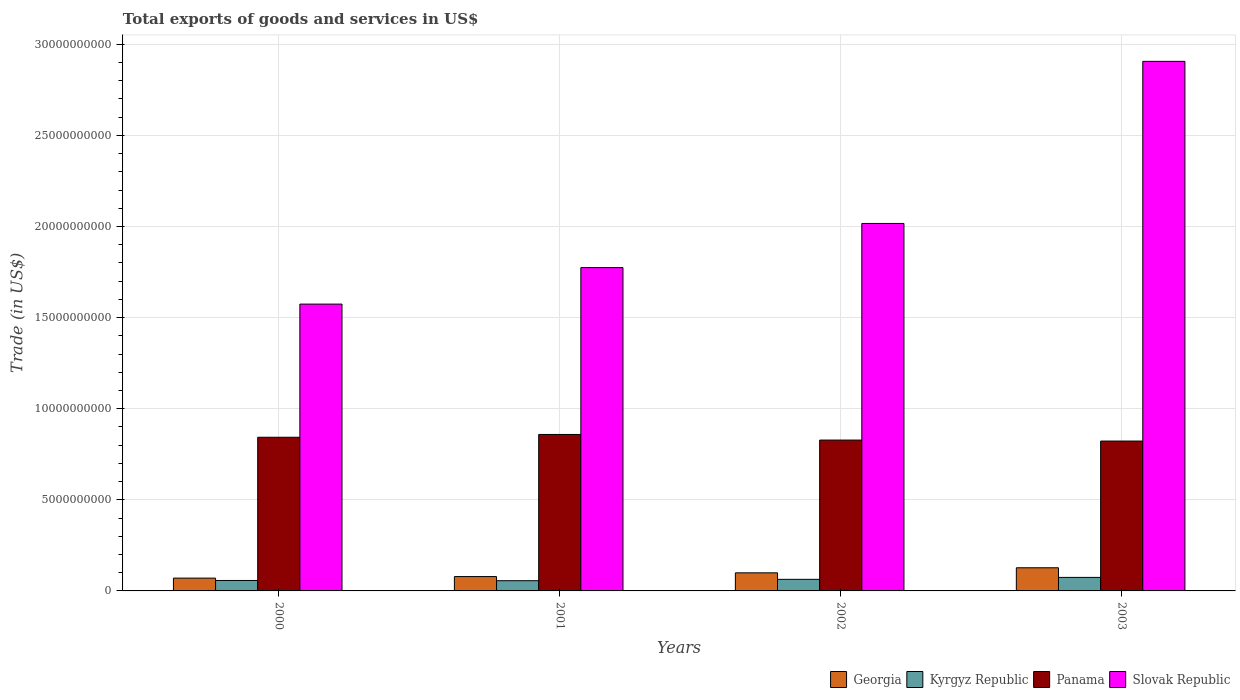How many groups of bars are there?
Your response must be concise. 4. Are the number of bars per tick equal to the number of legend labels?
Your answer should be very brief. Yes. Are the number of bars on each tick of the X-axis equal?
Make the answer very short. Yes. How many bars are there on the 3rd tick from the left?
Keep it short and to the point. 4. What is the total exports of goods and services in Slovak Republic in 2003?
Provide a short and direct response. 2.91e+1. Across all years, what is the maximum total exports of goods and services in Kyrgyz Republic?
Provide a short and direct response. 7.42e+08. Across all years, what is the minimum total exports of goods and services in Slovak Republic?
Ensure brevity in your answer.  1.57e+1. In which year was the total exports of goods and services in Georgia maximum?
Offer a terse response. 2003. In which year was the total exports of goods and services in Panama minimum?
Make the answer very short. 2003. What is the total total exports of goods and services in Panama in the graph?
Ensure brevity in your answer.  3.35e+1. What is the difference between the total exports of goods and services in Georgia in 2002 and that in 2003?
Your answer should be compact. -2.78e+08. What is the difference between the total exports of goods and services in Georgia in 2000 and the total exports of goods and services in Kyrgyz Republic in 2001?
Provide a succinct answer. 1.43e+08. What is the average total exports of goods and services in Georgia per year?
Your answer should be very brief. 9.38e+08. In the year 2003, what is the difference between the total exports of goods and services in Panama and total exports of goods and services in Slovak Republic?
Your response must be concise. -2.08e+1. What is the ratio of the total exports of goods and services in Slovak Republic in 2000 to that in 2003?
Offer a very short reply. 0.54. Is the total exports of goods and services in Kyrgyz Republic in 2001 less than that in 2002?
Keep it short and to the point. Yes. Is the difference between the total exports of goods and services in Panama in 2000 and 2002 greater than the difference between the total exports of goods and services in Slovak Republic in 2000 and 2002?
Give a very brief answer. Yes. What is the difference between the highest and the second highest total exports of goods and services in Slovak Republic?
Provide a short and direct response. 8.90e+09. What is the difference between the highest and the lowest total exports of goods and services in Panama?
Make the answer very short. 3.61e+08. Is it the case that in every year, the sum of the total exports of goods and services in Kyrgyz Republic and total exports of goods and services in Georgia is greater than the sum of total exports of goods and services in Panama and total exports of goods and services in Slovak Republic?
Ensure brevity in your answer.  No. What does the 2nd bar from the left in 2001 represents?
Provide a succinct answer. Kyrgyz Republic. What does the 1st bar from the right in 2002 represents?
Your answer should be very brief. Slovak Republic. How many years are there in the graph?
Your response must be concise. 4. Does the graph contain any zero values?
Make the answer very short. No. How many legend labels are there?
Provide a short and direct response. 4. How are the legend labels stacked?
Provide a short and direct response. Horizontal. What is the title of the graph?
Keep it short and to the point. Total exports of goods and services in US$. Does "Colombia" appear as one of the legend labels in the graph?
Your answer should be compact. No. What is the label or title of the Y-axis?
Offer a terse response. Trade (in US$). What is the Trade (in US$) in Georgia in 2000?
Provide a succinct answer. 7.03e+08. What is the Trade (in US$) in Kyrgyz Republic in 2000?
Your answer should be compact. 5.73e+08. What is the Trade (in US$) in Panama in 2000?
Ensure brevity in your answer.  8.43e+09. What is the Trade (in US$) in Slovak Republic in 2000?
Provide a succinct answer. 1.57e+1. What is the Trade (in US$) of Georgia in 2001?
Ensure brevity in your answer.  7.88e+08. What is the Trade (in US$) in Kyrgyz Republic in 2001?
Give a very brief answer. 5.60e+08. What is the Trade (in US$) of Panama in 2001?
Offer a very short reply. 8.59e+09. What is the Trade (in US$) in Slovak Republic in 2001?
Provide a short and direct response. 1.77e+1. What is the Trade (in US$) in Georgia in 2002?
Offer a very short reply. 9.93e+08. What is the Trade (in US$) of Kyrgyz Republic in 2002?
Your response must be concise. 6.36e+08. What is the Trade (in US$) of Panama in 2002?
Your answer should be very brief. 8.28e+09. What is the Trade (in US$) in Slovak Republic in 2002?
Ensure brevity in your answer.  2.02e+1. What is the Trade (in US$) in Georgia in 2003?
Your answer should be compact. 1.27e+09. What is the Trade (in US$) in Kyrgyz Republic in 2003?
Make the answer very short. 7.42e+08. What is the Trade (in US$) of Panama in 2003?
Make the answer very short. 8.23e+09. What is the Trade (in US$) in Slovak Republic in 2003?
Make the answer very short. 2.91e+1. Across all years, what is the maximum Trade (in US$) of Georgia?
Make the answer very short. 1.27e+09. Across all years, what is the maximum Trade (in US$) of Kyrgyz Republic?
Keep it short and to the point. 7.42e+08. Across all years, what is the maximum Trade (in US$) of Panama?
Provide a short and direct response. 8.59e+09. Across all years, what is the maximum Trade (in US$) in Slovak Republic?
Your answer should be very brief. 2.91e+1. Across all years, what is the minimum Trade (in US$) in Georgia?
Your answer should be very brief. 7.03e+08. Across all years, what is the minimum Trade (in US$) in Kyrgyz Republic?
Provide a short and direct response. 5.60e+08. Across all years, what is the minimum Trade (in US$) of Panama?
Your answer should be very brief. 8.23e+09. Across all years, what is the minimum Trade (in US$) of Slovak Republic?
Ensure brevity in your answer.  1.57e+1. What is the total Trade (in US$) of Georgia in the graph?
Offer a terse response. 3.75e+09. What is the total Trade (in US$) of Kyrgyz Republic in the graph?
Make the answer very short. 2.51e+09. What is the total Trade (in US$) of Panama in the graph?
Offer a terse response. 3.35e+1. What is the total Trade (in US$) of Slovak Republic in the graph?
Ensure brevity in your answer.  8.27e+1. What is the difference between the Trade (in US$) of Georgia in 2000 and that in 2001?
Provide a short and direct response. -8.45e+07. What is the difference between the Trade (in US$) of Kyrgyz Republic in 2000 and that in 2001?
Your answer should be very brief. 1.31e+07. What is the difference between the Trade (in US$) in Panama in 2000 and that in 2001?
Provide a short and direct response. -1.53e+08. What is the difference between the Trade (in US$) in Slovak Republic in 2000 and that in 2001?
Ensure brevity in your answer.  -2.00e+09. What is the difference between the Trade (in US$) of Georgia in 2000 and that in 2002?
Offer a terse response. -2.90e+08. What is the difference between the Trade (in US$) in Kyrgyz Republic in 2000 and that in 2002?
Give a very brief answer. -6.24e+07. What is the difference between the Trade (in US$) of Panama in 2000 and that in 2002?
Offer a terse response. 1.55e+08. What is the difference between the Trade (in US$) of Slovak Republic in 2000 and that in 2002?
Offer a terse response. -4.43e+09. What is the difference between the Trade (in US$) of Georgia in 2000 and that in 2003?
Make the answer very short. -5.68e+08. What is the difference between the Trade (in US$) in Kyrgyz Republic in 2000 and that in 2003?
Your response must be concise. -1.69e+08. What is the difference between the Trade (in US$) in Panama in 2000 and that in 2003?
Provide a succinct answer. 2.08e+08. What is the difference between the Trade (in US$) in Slovak Republic in 2000 and that in 2003?
Keep it short and to the point. -1.33e+1. What is the difference between the Trade (in US$) of Georgia in 2001 and that in 2002?
Offer a very short reply. -2.05e+08. What is the difference between the Trade (in US$) in Kyrgyz Republic in 2001 and that in 2002?
Your response must be concise. -7.54e+07. What is the difference between the Trade (in US$) in Panama in 2001 and that in 2002?
Your answer should be compact. 3.08e+08. What is the difference between the Trade (in US$) in Slovak Republic in 2001 and that in 2002?
Offer a very short reply. -2.42e+09. What is the difference between the Trade (in US$) of Georgia in 2001 and that in 2003?
Provide a short and direct response. -4.83e+08. What is the difference between the Trade (in US$) of Kyrgyz Republic in 2001 and that in 2003?
Give a very brief answer. -1.82e+08. What is the difference between the Trade (in US$) in Panama in 2001 and that in 2003?
Keep it short and to the point. 3.61e+08. What is the difference between the Trade (in US$) in Slovak Republic in 2001 and that in 2003?
Ensure brevity in your answer.  -1.13e+1. What is the difference between the Trade (in US$) of Georgia in 2002 and that in 2003?
Make the answer very short. -2.78e+08. What is the difference between the Trade (in US$) of Kyrgyz Republic in 2002 and that in 2003?
Provide a short and direct response. -1.07e+08. What is the difference between the Trade (in US$) in Panama in 2002 and that in 2003?
Keep it short and to the point. 5.37e+07. What is the difference between the Trade (in US$) in Slovak Republic in 2002 and that in 2003?
Make the answer very short. -8.90e+09. What is the difference between the Trade (in US$) in Georgia in 2000 and the Trade (in US$) in Kyrgyz Republic in 2001?
Offer a very short reply. 1.43e+08. What is the difference between the Trade (in US$) of Georgia in 2000 and the Trade (in US$) of Panama in 2001?
Offer a terse response. -7.88e+09. What is the difference between the Trade (in US$) of Georgia in 2000 and the Trade (in US$) of Slovak Republic in 2001?
Keep it short and to the point. -1.70e+1. What is the difference between the Trade (in US$) of Kyrgyz Republic in 2000 and the Trade (in US$) of Panama in 2001?
Offer a terse response. -8.01e+09. What is the difference between the Trade (in US$) of Kyrgyz Republic in 2000 and the Trade (in US$) of Slovak Republic in 2001?
Your response must be concise. -1.72e+1. What is the difference between the Trade (in US$) in Panama in 2000 and the Trade (in US$) in Slovak Republic in 2001?
Your answer should be compact. -9.31e+09. What is the difference between the Trade (in US$) of Georgia in 2000 and the Trade (in US$) of Kyrgyz Republic in 2002?
Offer a terse response. 6.75e+07. What is the difference between the Trade (in US$) of Georgia in 2000 and the Trade (in US$) of Panama in 2002?
Offer a very short reply. -7.58e+09. What is the difference between the Trade (in US$) of Georgia in 2000 and the Trade (in US$) of Slovak Republic in 2002?
Offer a terse response. -1.95e+1. What is the difference between the Trade (in US$) of Kyrgyz Republic in 2000 and the Trade (in US$) of Panama in 2002?
Offer a very short reply. -7.71e+09. What is the difference between the Trade (in US$) of Kyrgyz Republic in 2000 and the Trade (in US$) of Slovak Republic in 2002?
Keep it short and to the point. -1.96e+1. What is the difference between the Trade (in US$) of Panama in 2000 and the Trade (in US$) of Slovak Republic in 2002?
Offer a very short reply. -1.17e+1. What is the difference between the Trade (in US$) in Georgia in 2000 and the Trade (in US$) in Kyrgyz Republic in 2003?
Your answer should be compact. -3.92e+07. What is the difference between the Trade (in US$) of Georgia in 2000 and the Trade (in US$) of Panama in 2003?
Keep it short and to the point. -7.52e+09. What is the difference between the Trade (in US$) in Georgia in 2000 and the Trade (in US$) in Slovak Republic in 2003?
Your answer should be compact. -2.84e+1. What is the difference between the Trade (in US$) of Kyrgyz Republic in 2000 and the Trade (in US$) of Panama in 2003?
Provide a succinct answer. -7.65e+09. What is the difference between the Trade (in US$) of Kyrgyz Republic in 2000 and the Trade (in US$) of Slovak Republic in 2003?
Your answer should be compact. -2.85e+1. What is the difference between the Trade (in US$) in Panama in 2000 and the Trade (in US$) in Slovak Republic in 2003?
Make the answer very short. -2.06e+1. What is the difference between the Trade (in US$) of Georgia in 2001 and the Trade (in US$) of Kyrgyz Republic in 2002?
Provide a short and direct response. 1.52e+08. What is the difference between the Trade (in US$) of Georgia in 2001 and the Trade (in US$) of Panama in 2002?
Offer a very short reply. -7.49e+09. What is the difference between the Trade (in US$) of Georgia in 2001 and the Trade (in US$) of Slovak Republic in 2002?
Your answer should be very brief. -1.94e+1. What is the difference between the Trade (in US$) in Kyrgyz Republic in 2001 and the Trade (in US$) in Panama in 2002?
Keep it short and to the point. -7.72e+09. What is the difference between the Trade (in US$) of Kyrgyz Republic in 2001 and the Trade (in US$) of Slovak Republic in 2002?
Keep it short and to the point. -1.96e+1. What is the difference between the Trade (in US$) of Panama in 2001 and the Trade (in US$) of Slovak Republic in 2002?
Your answer should be very brief. -1.16e+1. What is the difference between the Trade (in US$) in Georgia in 2001 and the Trade (in US$) in Kyrgyz Republic in 2003?
Your response must be concise. 4.52e+07. What is the difference between the Trade (in US$) in Georgia in 2001 and the Trade (in US$) in Panama in 2003?
Offer a very short reply. -7.44e+09. What is the difference between the Trade (in US$) in Georgia in 2001 and the Trade (in US$) in Slovak Republic in 2003?
Make the answer very short. -2.83e+1. What is the difference between the Trade (in US$) of Kyrgyz Republic in 2001 and the Trade (in US$) of Panama in 2003?
Your answer should be very brief. -7.67e+09. What is the difference between the Trade (in US$) of Kyrgyz Republic in 2001 and the Trade (in US$) of Slovak Republic in 2003?
Your response must be concise. -2.85e+1. What is the difference between the Trade (in US$) of Panama in 2001 and the Trade (in US$) of Slovak Republic in 2003?
Your answer should be compact. -2.05e+1. What is the difference between the Trade (in US$) of Georgia in 2002 and the Trade (in US$) of Kyrgyz Republic in 2003?
Offer a very short reply. 2.50e+08. What is the difference between the Trade (in US$) of Georgia in 2002 and the Trade (in US$) of Panama in 2003?
Provide a succinct answer. -7.23e+09. What is the difference between the Trade (in US$) of Georgia in 2002 and the Trade (in US$) of Slovak Republic in 2003?
Provide a succinct answer. -2.81e+1. What is the difference between the Trade (in US$) of Kyrgyz Republic in 2002 and the Trade (in US$) of Panama in 2003?
Provide a short and direct response. -7.59e+09. What is the difference between the Trade (in US$) in Kyrgyz Republic in 2002 and the Trade (in US$) in Slovak Republic in 2003?
Your answer should be compact. -2.84e+1. What is the difference between the Trade (in US$) of Panama in 2002 and the Trade (in US$) of Slovak Republic in 2003?
Your response must be concise. -2.08e+1. What is the average Trade (in US$) in Georgia per year?
Provide a succinct answer. 9.38e+08. What is the average Trade (in US$) of Kyrgyz Republic per year?
Give a very brief answer. 6.28e+08. What is the average Trade (in US$) in Panama per year?
Provide a short and direct response. 8.38e+09. What is the average Trade (in US$) in Slovak Republic per year?
Make the answer very short. 2.07e+1. In the year 2000, what is the difference between the Trade (in US$) of Georgia and Trade (in US$) of Kyrgyz Republic?
Offer a terse response. 1.30e+08. In the year 2000, what is the difference between the Trade (in US$) of Georgia and Trade (in US$) of Panama?
Your response must be concise. -7.73e+09. In the year 2000, what is the difference between the Trade (in US$) in Georgia and Trade (in US$) in Slovak Republic?
Your answer should be very brief. -1.50e+1. In the year 2000, what is the difference between the Trade (in US$) in Kyrgyz Republic and Trade (in US$) in Panama?
Make the answer very short. -7.86e+09. In the year 2000, what is the difference between the Trade (in US$) in Kyrgyz Republic and Trade (in US$) in Slovak Republic?
Your answer should be very brief. -1.52e+1. In the year 2000, what is the difference between the Trade (in US$) of Panama and Trade (in US$) of Slovak Republic?
Make the answer very short. -7.31e+09. In the year 2001, what is the difference between the Trade (in US$) of Georgia and Trade (in US$) of Kyrgyz Republic?
Your answer should be compact. 2.27e+08. In the year 2001, what is the difference between the Trade (in US$) of Georgia and Trade (in US$) of Panama?
Keep it short and to the point. -7.80e+09. In the year 2001, what is the difference between the Trade (in US$) of Georgia and Trade (in US$) of Slovak Republic?
Keep it short and to the point. -1.70e+1. In the year 2001, what is the difference between the Trade (in US$) of Kyrgyz Republic and Trade (in US$) of Panama?
Give a very brief answer. -8.03e+09. In the year 2001, what is the difference between the Trade (in US$) of Kyrgyz Republic and Trade (in US$) of Slovak Republic?
Your response must be concise. -1.72e+1. In the year 2001, what is the difference between the Trade (in US$) of Panama and Trade (in US$) of Slovak Republic?
Provide a short and direct response. -9.16e+09. In the year 2002, what is the difference between the Trade (in US$) in Georgia and Trade (in US$) in Kyrgyz Republic?
Your response must be concise. 3.57e+08. In the year 2002, what is the difference between the Trade (in US$) in Georgia and Trade (in US$) in Panama?
Your response must be concise. -7.29e+09. In the year 2002, what is the difference between the Trade (in US$) of Georgia and Trade (in US$) of Slovak Republic?
Ensure brevity in your answer.  -1.92e+1. In the year 2002, what is the difference between the Trade (in US$) in Kyrgyz Republic and Trade (in US$) in Panama?
Offer a very short reply. -7.64e+09. In the year 2002, what is the difference between the Trade (in US$) in Kyrgyz Republic and Trade (in US$) in Slovak Republic?
Ensure brevity in your answer.  -1.95e+1. In the year 2002, what is the difference between the Trade (in US$) in Panama and Trade (in US$) in Slovak Republic?
Your answer should be very brief. -1.19e+1. In the year 2003, what is the difference between the Trade (in US$) in Georgia and Trade (in US$) in Kyrgyz Republic?
Provide a succinct answer. 5.28e+08. In the year 2003, what is the difference between the Trade (in US$) in Georgia and Trade (in US$) in Panama?
Your answer should be very brief. -6.95e+09. In the year 2003, what is the difference between the Trade (in US$) in Georgia and Trade (in US$) in Slovak Republic?
Offer a terse response. -2.78e+1. In the year 2003, what is the difference between the Trade (in US$) of Kyrgyz Republic and Trade (in US$) of Panama?
Ensure brevity in your answer.  -7.48e+09. In the year 2003, what is the difference between the Trade (in US$) in Kyrgyz Republic and Trade (in US$) in Slovak Republic?
Your response must be concise. -2.83e+1. In the year 2003, what is the difference between the Trade (in US$) of Panama and Trade (in US$) of Slovak Republic?
Your response must be concise. -2.08e+1. What is the ratio of the Trade (in US$) in Georgia in 2000 to that in 2001?
Your answer should be very brief. 0.89. What is the ratio of the Trade (in US$) in Kyrgyz Republic in 2000 to that in 2001?
Provide a succinct answer. 1.02. What is the ratio of the Trade (in US$) of Panama in 2000 to that in 2001?
Ensure brevity in your answer.  0.98. What is the ratio of the Trade (in US$) in Slovak Republic in 2000 to that in 2001?
Your answer should be very brief. 0.89. What is the ratio of the Trade (in US$) in Georgia in 2000 to that in 2002?
Your response must be concise. 0.71. What is the ratio of the Trade (in US$) of Kyrgyz Republic in 2000 to that in 2002?
Offer a very short reply. 0.9. What is the ratio of the Trade (in US$) in Panama in 2000 to that in 2002?
Your answer should be compact. 1.02. What is the ratio of the Trade (in US$) in Slovak Republic in 2000 to that in 2002?
Your response must be concise. 0.78. What is the ratio of the Trade (in US$) in Georgia in 2000 to that in 2003?
Provide a short and direct response. 0.55. What is the ratio of the Trade (in US$) of Kyrgyz Republic in 2000 to that in 2003?
Keep it short and to the point. 0.77. What is the ratio of the Trade (in US$) of Panama in 2000 to that in 2003?
Offer a very short reply. 1.03. What is the ratio of the Trade (in US$) of Slovak Republic in 2000 to that in 2003?
Offer a terse response. 0.54. What is the ratio of the Trade (in US$) of Georgia in 2001 to that in 2002?
Make the answer very short. 0.79. What is the ratio of the Trade (in US$) in Kyrgyz Republic in 2001 to that in 2002?
Give a very brief answer. 0.88. What is the ratio of the Trade (in US$) in Panama in 2001 to that in 2002?
Your answer should be very brief. 1.04. What is the ratio of the Trade (in US$) in Slovak Republic in 2001 to that in 2002?
Give a very brief answer. 0.88. What is the ratio of the Trade (in US$) in Georgia in 2001 to that in 2003?
Provide a short and direct response. 0.62. What is the ratio of the Trade (in US$) of Kyrgyz Republic in 2001 to that in 2003?
Offer a terse response. 0.75. What is the ratio of the Trade (in US$) of Panama in 2001 to that in 2003?
Keep it short and to the point. 1.04. What is the ratio of the Trade (in US$) of Slovak Republic in 2001 to that in 2003?
Your answer should be compact. 0.61. What is the ratio of the Trade (in US$) in Georgia in 2002 to that in 2003?
Your answer should be very brief. 0.78. What is the ratio of the Trade (in US$) of Kyrgyz Republic in 2002 to that in 2003?
Give a very brief answer. 0.86. What is the ratio of the Trade (in US$) in Panama in 2002 to that in 2003?
Offer a very short reply. 1.01. What is the ratio of the Trade (in US$) of Slovak Republic in 2002 to that in 2003?
Offer a terse response. 0.69. What is the difference between the highest and the second highest Trade (in US$) in Georgia?
Offer a very short reply. 2.78e+08. What is the difference between the highest and the second highest Trade (in US$) of Kyrgyz Republic?
Give a very brief answer. 1.07e+08. What is the difference between the highest and the second highest Trade (in US$) in Panama?
Provide a succinct answer. 1.53e+08. What is the difference between the highest and the second highest Trade (in US$) of Slovak Republic?
Provide a short and direct response. 8.90e+09. What is the difference between the highest and the lowest Trade (in US$) in Georgia?
Your answer should be compact. 5.68e+08. What is the difference between the highest and the lowest Trade (in US$) in Kyrgyz Republic?
Offer a terse response. 1.82e+08. What is the difference between the highest and the lowest Trade (in US$) of Panama?
Make the answer very short. 3.61e+08. What is the difference between the highest and the lowest Trade (in US$) in Slovak Republic?
Provide a short and direct response. 1.33e+1. 